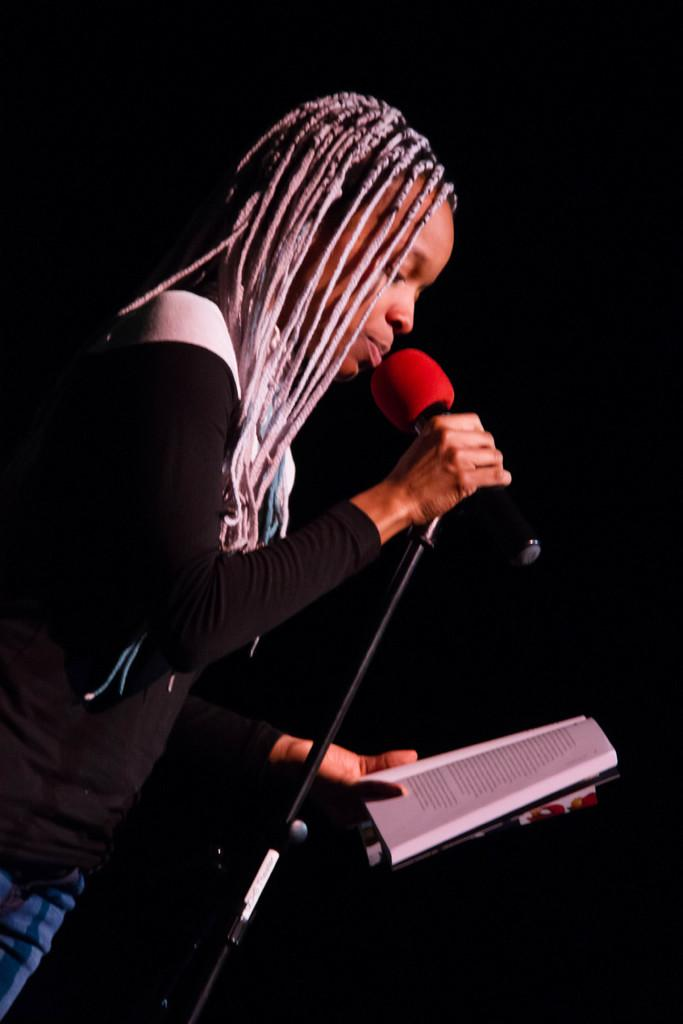Who is the main subject in the image? There is a girl in the image. What is the girl wearing? The girl is wearing a black t-shirt. What is the girl holding in her hand? The girl is holding a book in her hand. What is the girl doing with the book? The girl is reading from a microphone. What is the color of the background in the image? The background in the image is black. Can you see a rifle in the girl's hand in the image? No, there is no rifle present in the image. What type of feather is the girl using to read from the microphone? There is no feather present in the image; the girl is reading from a microphone using a book. 